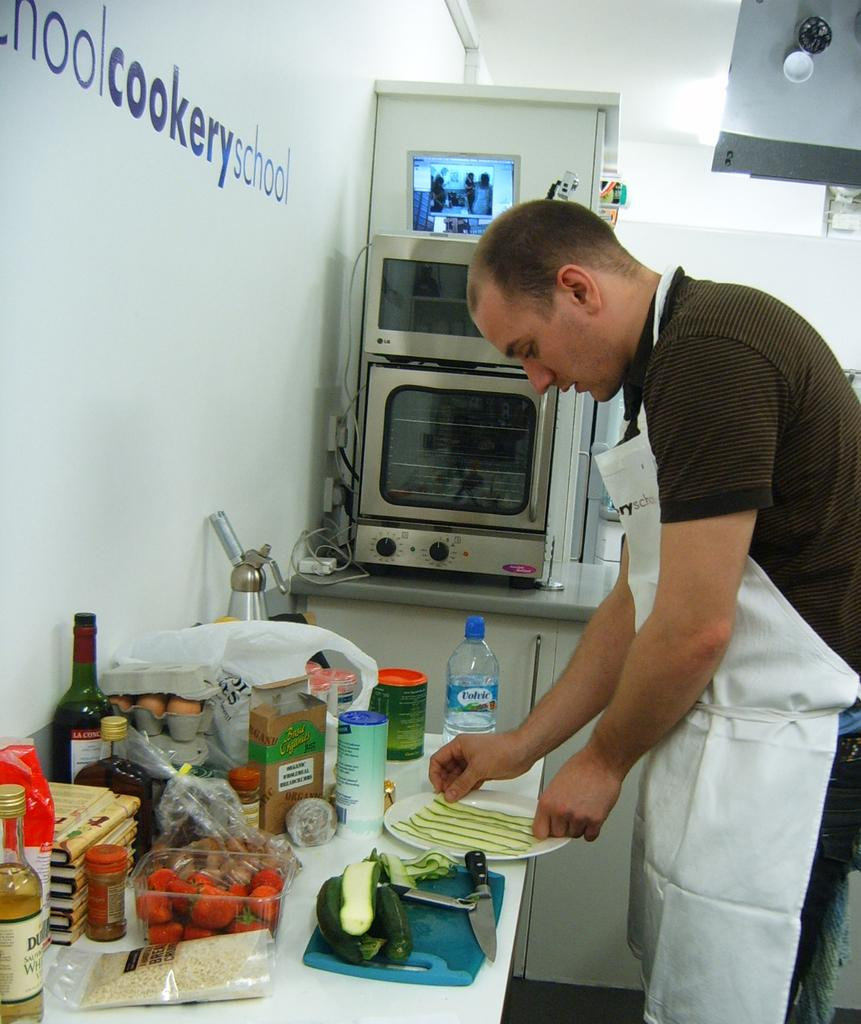<image>
Give a short and clear explanation of the subsequent image. A man prepares food at a counter under a wall that says cookery school. 